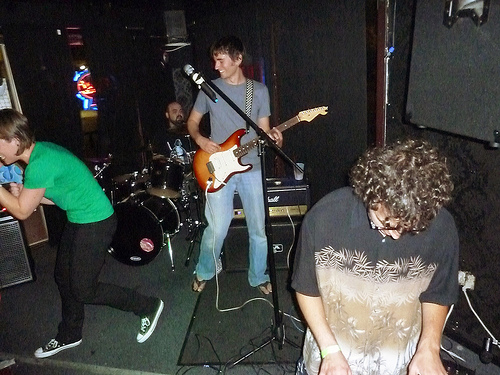<image>
Is the pant leg in front of the guitar? No. The pant leg is not in front of the guitar. The spatial positioning shows a different relationship between these objects. 